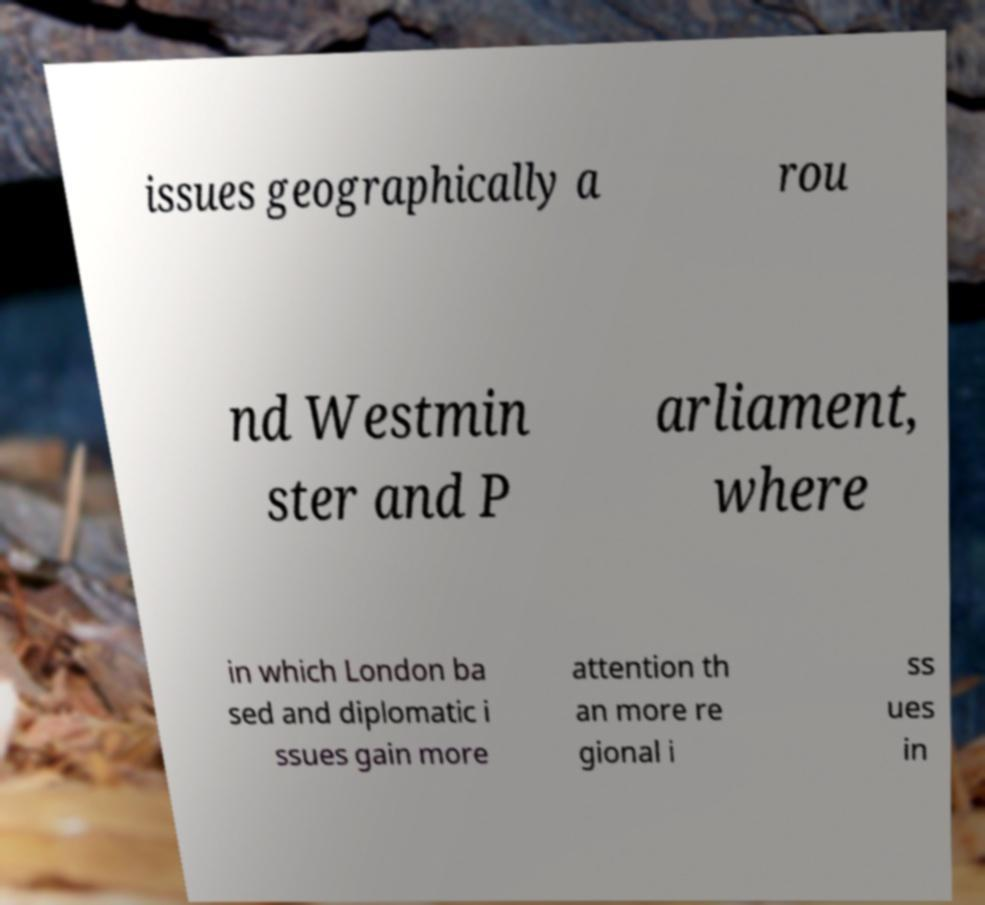I need the written content from this picture converted into text. Can you do that? issues geographically a rou nd Westmin ster and P arliament, where in which London ba sed and diplomatic i ssues gain more attention th an more re gional i ss ues in 